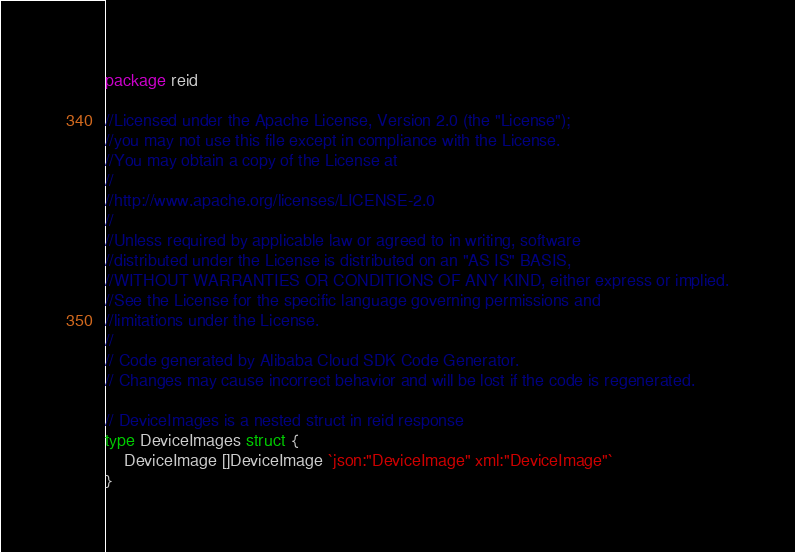Convert code to text. <code><loc_0><loc_0><loc_500><loc_500><_Go_>package reid

//Licensed under the Apache License, Version 2.0 (the "License");
//you may not use this file except in compliance with the License.
//You may obtain a copy of the License at
//
//http://www.apache.org/licenses/LICENSE-2.0
//
//Unless required by applicable law or agreed to in writing, software
//distributed under the License is distributed on an "AS IS" BASIS,
//WITHOUT WARRANTIES OR CONDITIONS OF ANY KIND, either express or implied.
//See the License for the specific language governing permissions and
//limitations under the License.
//
// Code generated by Alibaba Cloud SDK Code Generator.
// Changes may cause incorrect behavior and will be lost if the code is regenerated.

// DeviceImages is a nested struct in reid response
type DeviceImages struct {
	DeviceImage []DeviceImage `json:"DeviceImage" xml:"DeviceImage"`
}
</code> 